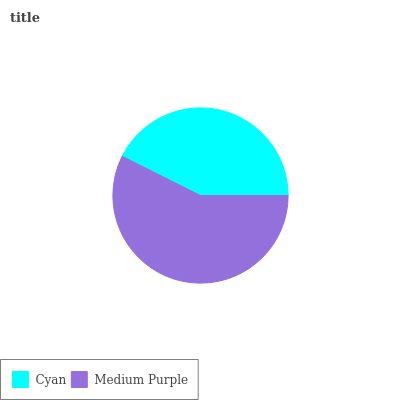Is Cyan the minimum?
Answer yes or no. Yes. Is Medium Purple the maximum?
Answer yes or no. Yes. Is Medium Purple the minimum?
Answer yes or no. No. Is Medium Purple greater than Cyan?
Answer yes or no. Yes. Is Cyan less than Medium Purple?
Answer yes or no. Yes. Is Cyan greater than Medium Purple?
Answer yes or no. No. Is Medium Purple less than Cyan?
Answer yes or no. No. Is Medium Purple the high median?
Answer yes or no. Yes. Is Cyan the low median?
Answer yes or no. Yes. Is Cyan the high median?
Answer yes or no. No. Is Medium Purple the low median?
Answer yes or no. No. 